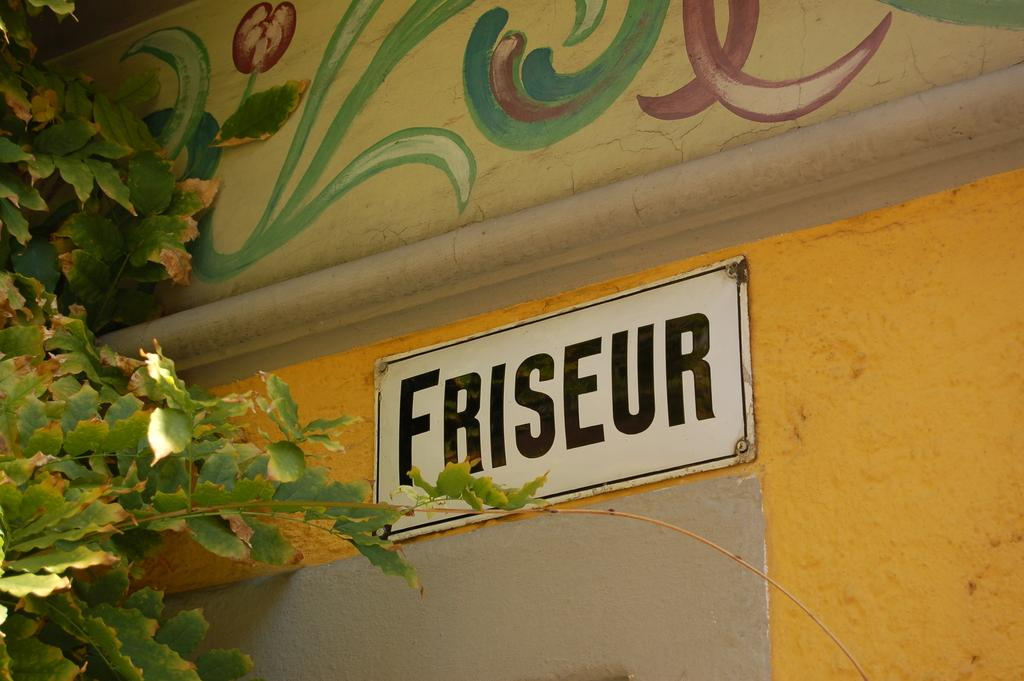What is the main object in the image? There is a white color board in the image. How is the white color board attached to the wall? The white color board is fixed to a yellow color wall. What can be seen on the wall besides the white color board? There is a design on the wall. What is located on the left side of the image? There is a tree on the left side of the image. Where is the sofa placed in the image? There is no sofa present in the image. How does the tree fall in the image? The tree does not fall in the image; it is standing on the left side. 